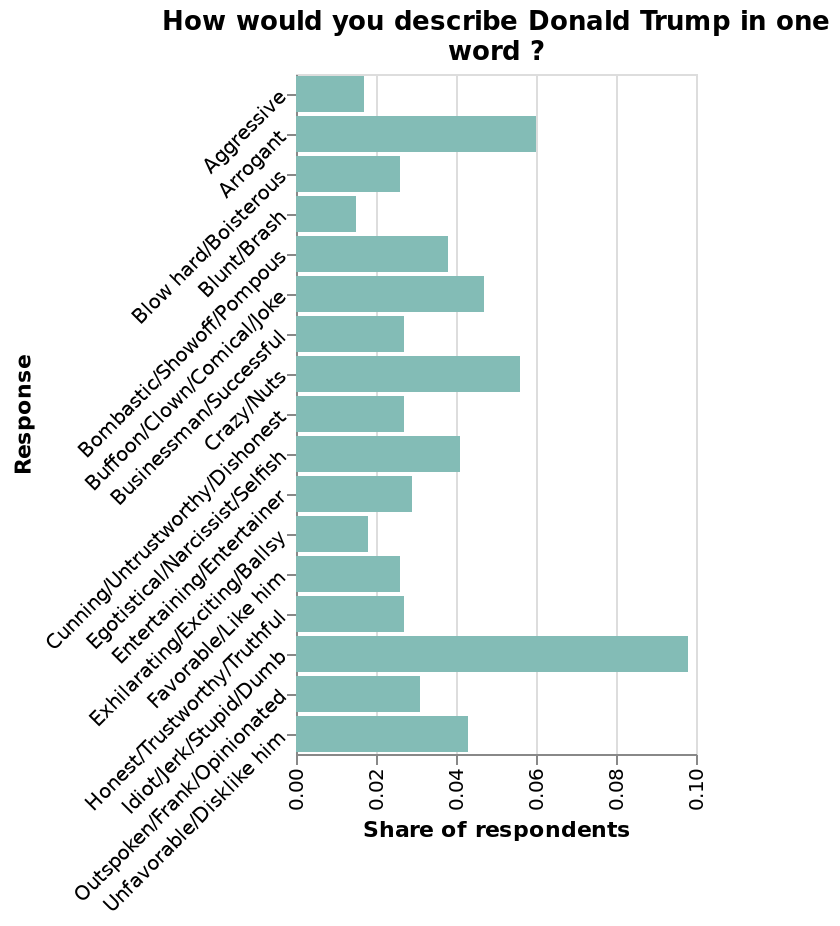<image>
How do people perceive Trump's sense of humor?  An average amount of people think he's funny and compare him to a clown. What is the name of the bar chart? The bar chart is named "How would you describe Donald Trump in one word?". Offer a thorough analysis of the image. The most common response by some distance is Idiot/Jerk/Stupid/Dumb. The next most common responses are also negative descriptions. What are some negative words used to describe Trump?  Unfavorable words such as idiot, crazy, and arrogant are often associated with Trump. 